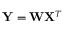<formula> <loc_0><loc_0><loc_500><loc_500>Y = { W } X ^ { T }</formula> 